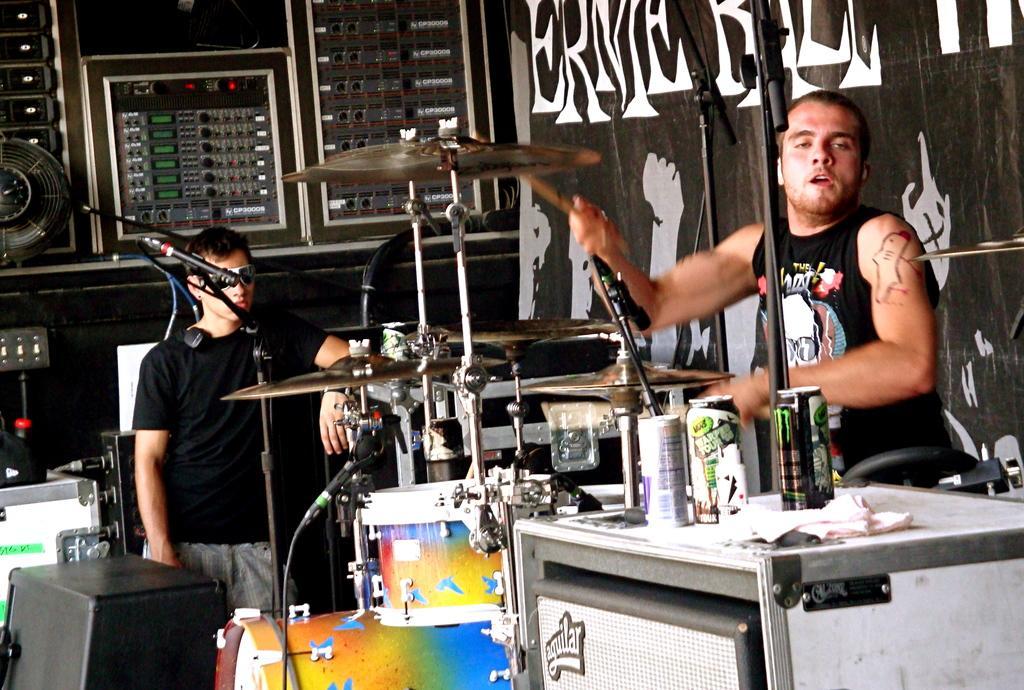Can you describe this image briefly? On the right there is a man who is playing the drum. On the bottom right we can see coke cans, cloth and other objects on the white color box. On the bottom left corner there is a speaker. Here we can see a man who is wearing black t-shirt and trouser, standing near to the mic. On the background we can see musical instrument and a banner. 